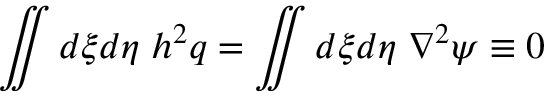<formula> <loc_0><loc_0><loc_500><loc_500>\iint d \xi d \eta \, h ^ { 2 } q = \iint d \xi d \eta \, \nabla ^ { 2 } \psi \equiv 0</formula> 